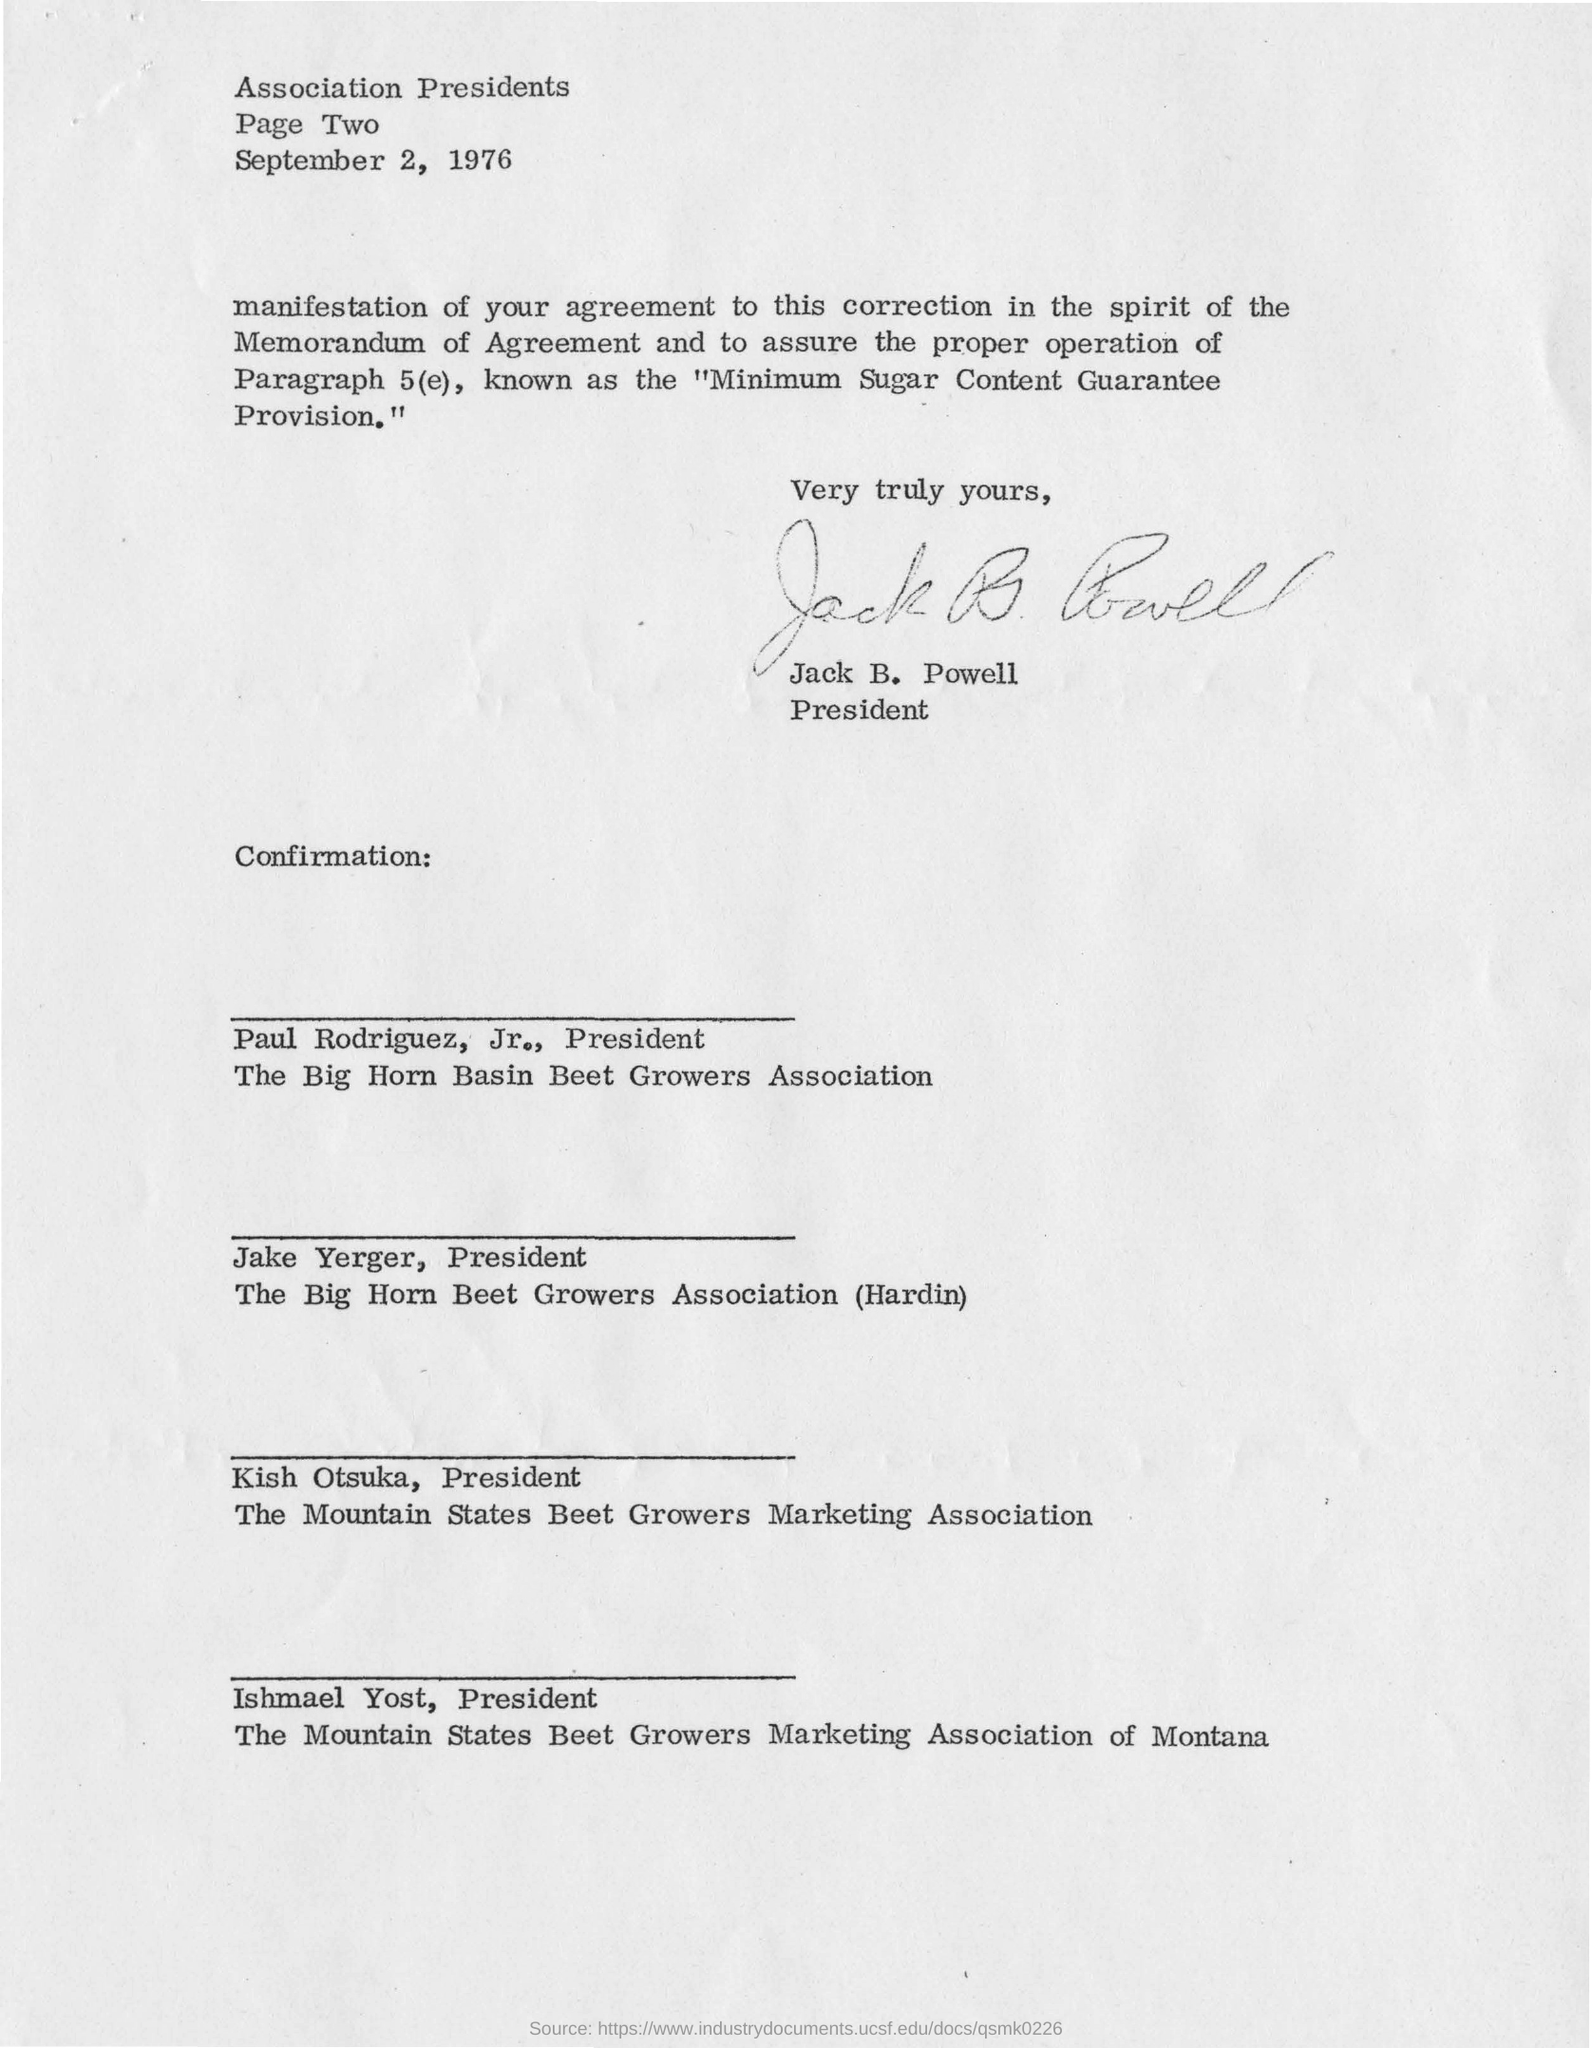Who is the letter from?
Offer a very short reply. Jack B. Powell. 